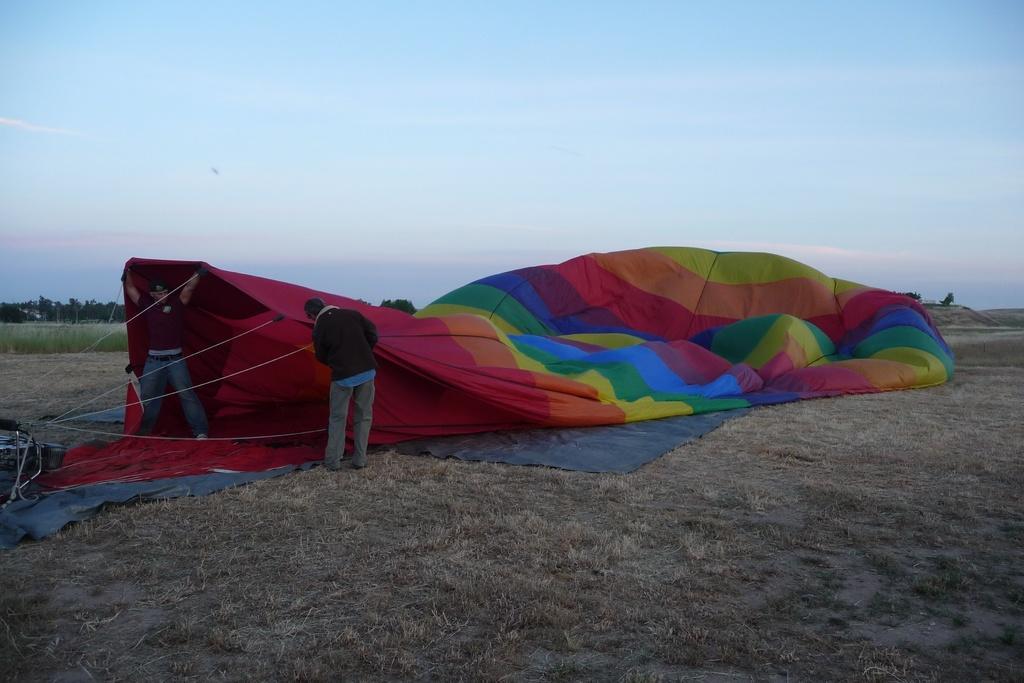How would you summarize this image in a sentence or two? In the center of the image there is a parachute. On the left there are people standing. In the background there are trees, grass and sky. 